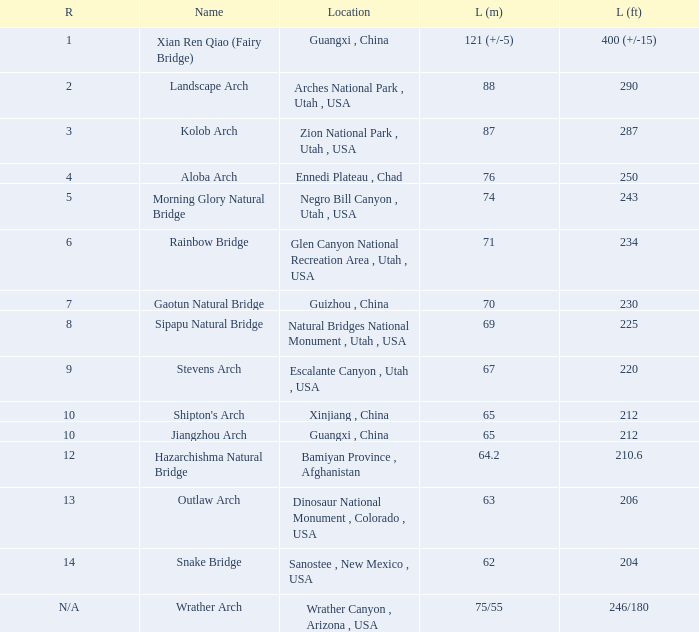Where is the longest arch with a length in meters of 63? Dinosaur National Monument , Colorado , USA. 